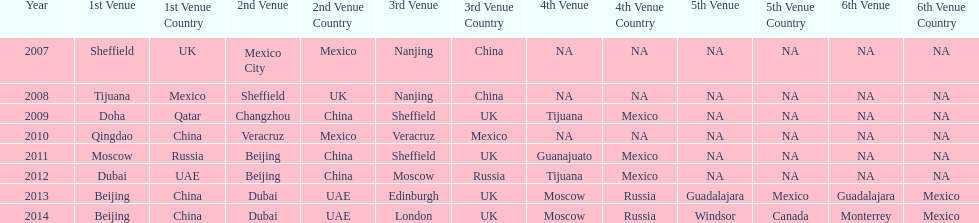Which is the only year that mexico is on a venue 2007. 